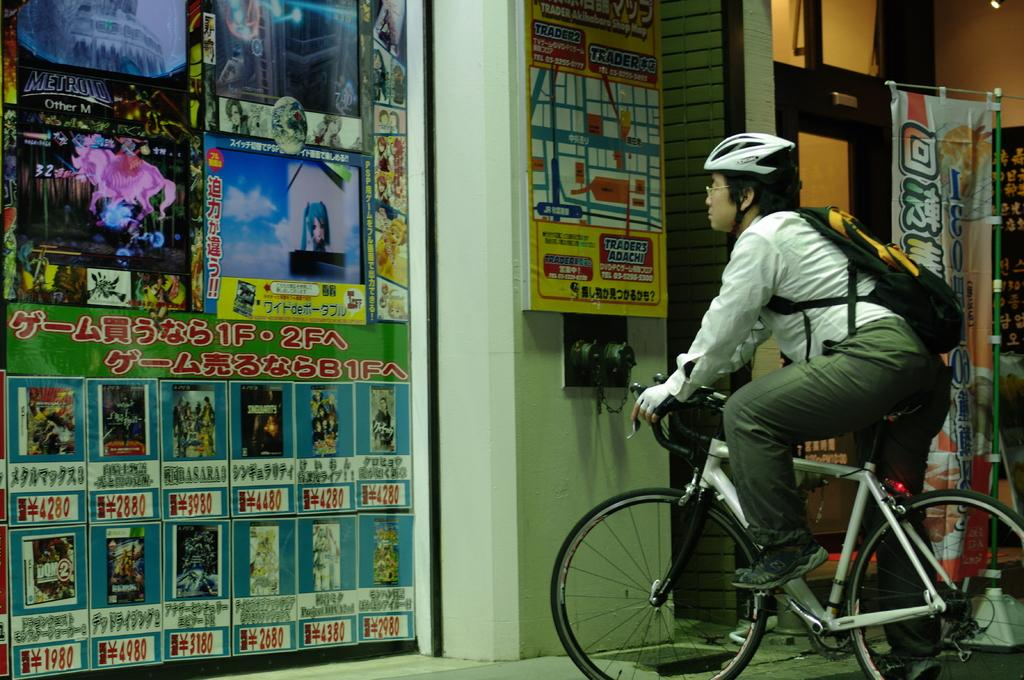Who is the main subject in the image? There is a man in the image. What is the man doing in the image? The man is sitting on a bicycle and observing a hoarding. Where is the hoarding located in the image? The hoarding is fixed to a wall. What type of marble is the man holding in the image? There is no marble present in the image; the man is sitting on a bicycle and observing a hoarding. 